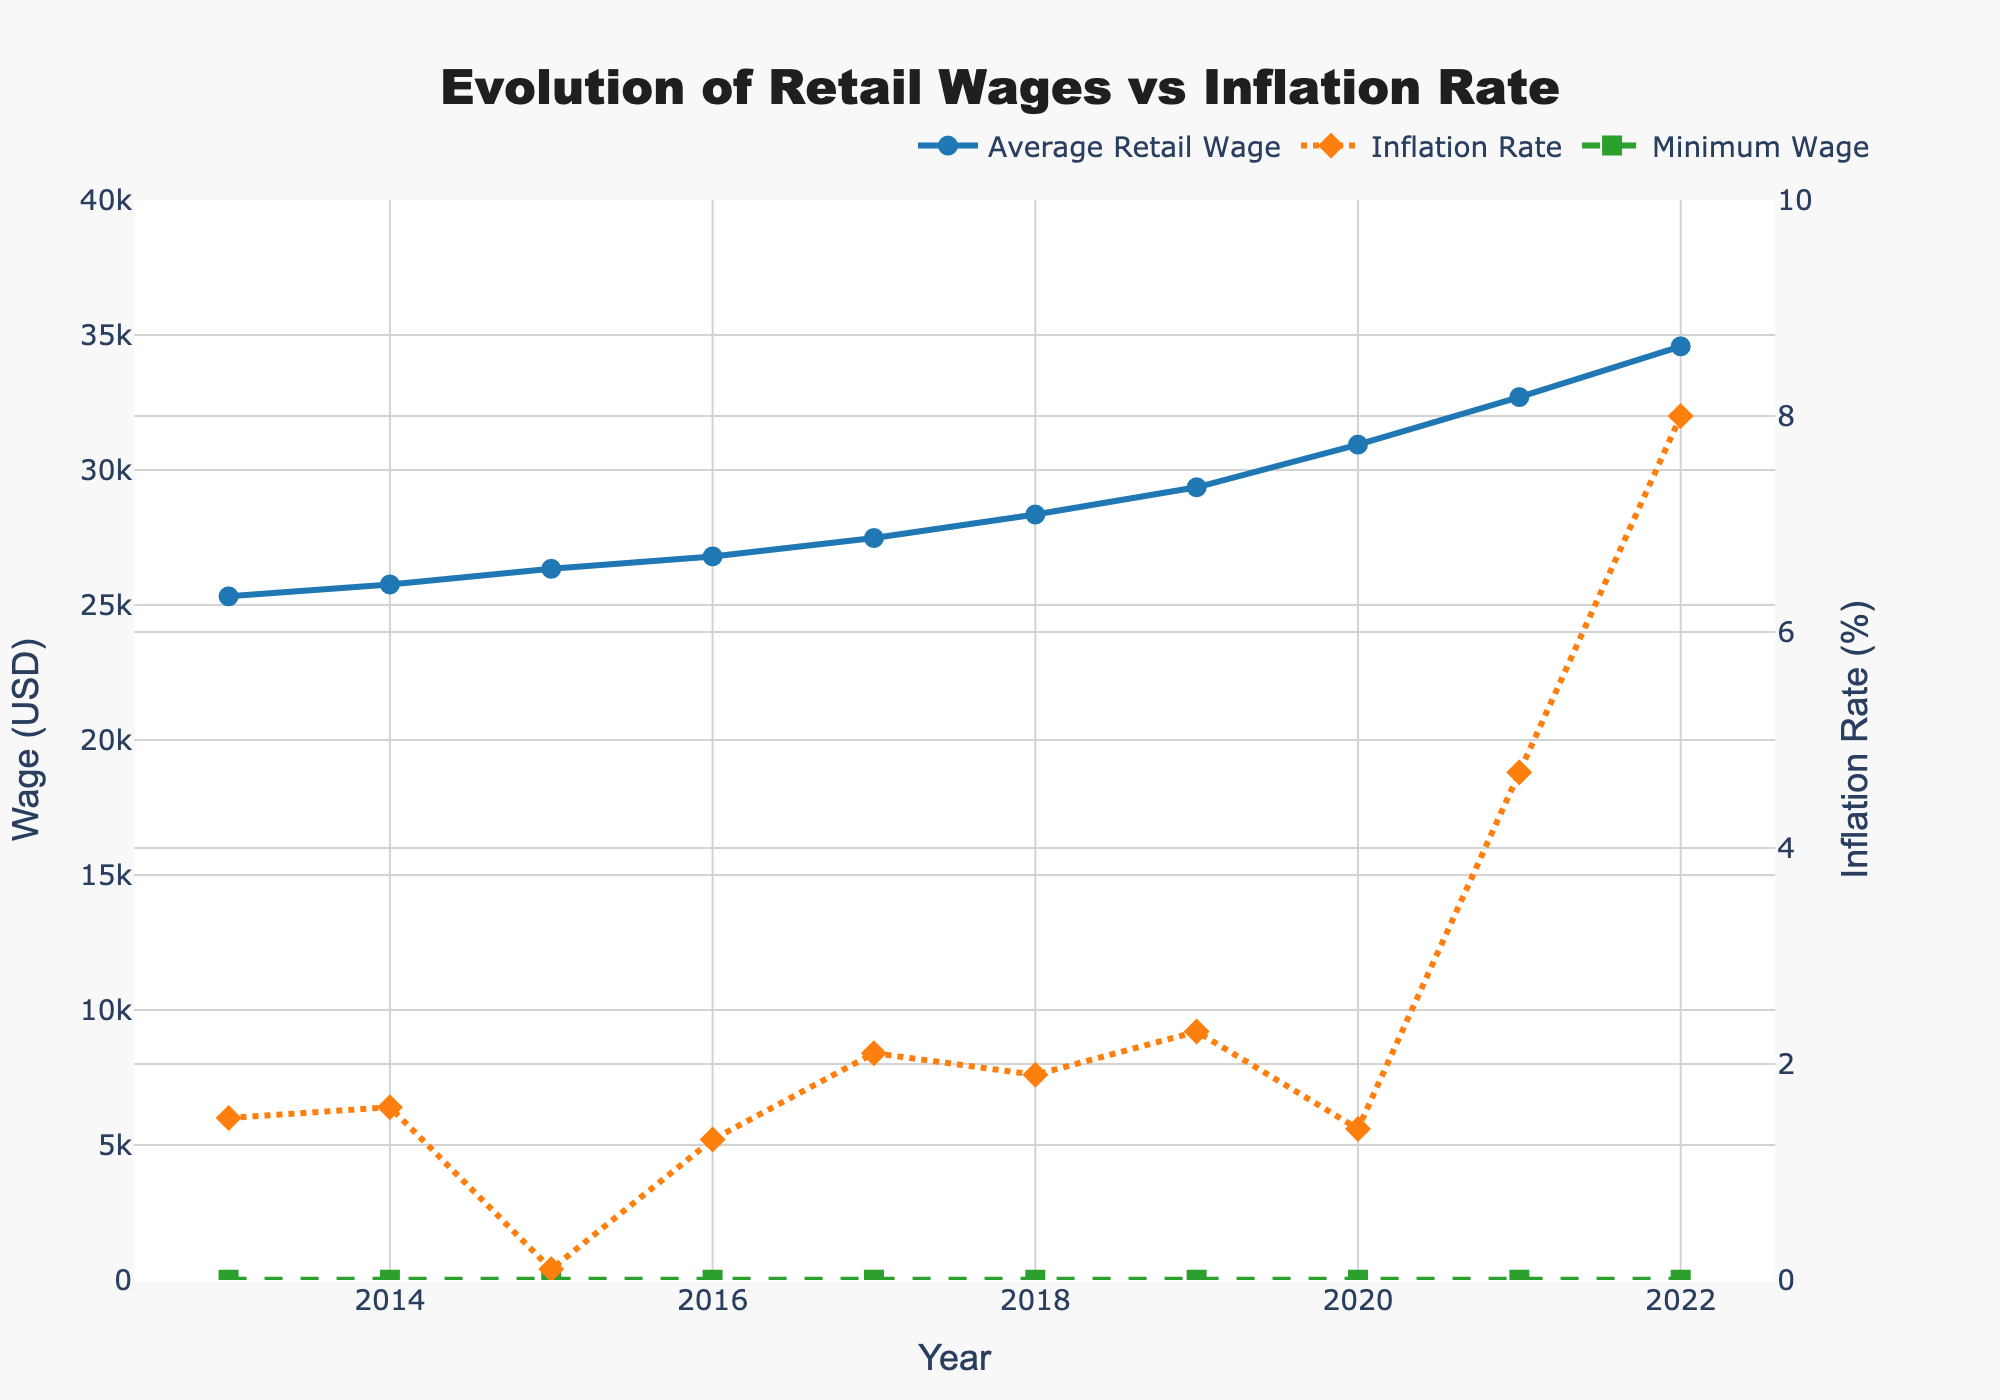What year did the average retail wage first exceed $30,000? Look at the "Average Retail Wage" series in the plot and find the first year where the marker is above the $30,000 line. This happens in 2020.
Answer: 2020 Which year shows the largest difference between the inflation rate and the average retail wage? Calculate the differences between the inflation rate and average retail wage for each year, then identify the year with the largest difference. The largest difference occurred in 2022.
Answer: 2022 In how many years did the inflation rate exceed 3%? Check the "Inflation Rate" series and count how many times the markers are above the 3% line. It is only in 2021 and 2022.
Answer: 2 years Between 2013 and 2022, did the average retail wage increase every year or were there any decreases? Visually inspect the line representing "Average Retail Wage" and note the pattern, which shows a consistent upward trend without any decreases.
Answer: Increased every year How does the minimum wage compare to the average retail wage across the years? Compare the lines representing "Minimum Wage" and "Average Retail Wage". The minimum wage is significantly lower than the average retail wage every year and does not change at all over the years.
Answer: Minimum wage is much lower and constant What is the average inflation rate over the years shown? Add up the inflation rates for each year and divide by the number of years. The sum of inflation rates is 24.9%, and there are 10 years in total. Thus, the average is 24.9/10 = 2.49%.
Answer: 2.49% Compare the slopes of the average retail wage trend and the inflation rate trend from 2013 to 2022. Visually assess the steepness of the "Average Retail Wage" line compared to the "Inflation Rate" line. The slope of the average retail wage trend is consistently upward while the inflation rate has more fluctuations and sharp changes in certain years.
Answer: Wage trend is steadier and upward, inflation fluctuates In which year was the difference between average retail wage and inflation rate the smallest? Identify the points in the plot where the difference between the "Average Retail Wage" line and "Inflation Rate" line is smallest by visual inspection. The smallest difference is observed around 2019.
Answer: 2019 What is the overall increase in the average retail wage from 2013 to 2022? Subtract the initial value of the average retail wage in 2013 from the final value in 2022. The increase is 34580 - 25320 = 9270 USD.
Answer: 9270 USD Did the minimum wage change at any point during the period from 2013 to 2022? Look at the "Minimum Wage" series in the chart. Observe that it remains at the same level of $7.25 throughout all years.
Answer: No, it did not change 